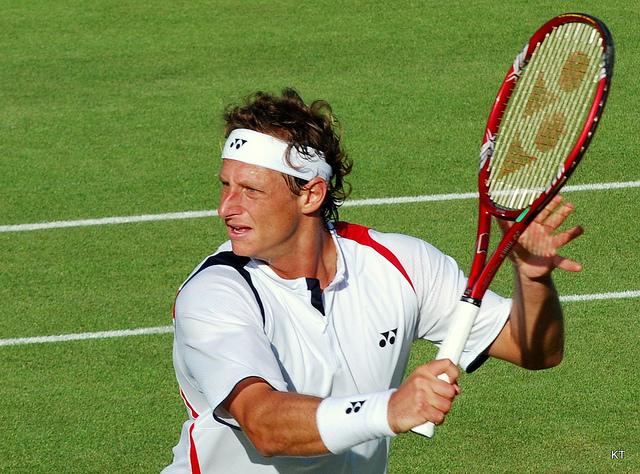What is the man holding in his hand?
Give a very brief answer. Tennis racket. Is the man pictured resting?
Write a very short answer. No. Is the player tired?
Concise answer only. Yes. 